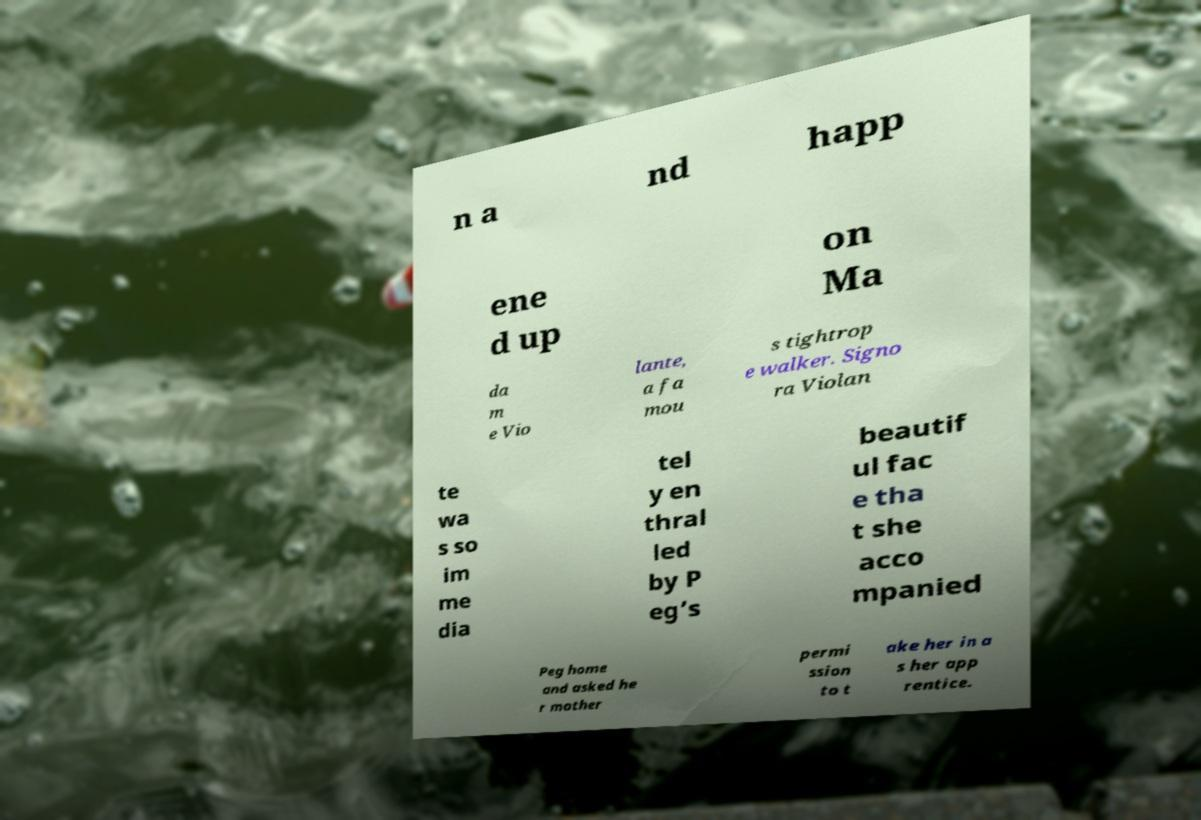What messages or text are displayed in this image? I need them in a readable, typed format. n a nd happ ene d up on Ma da m e Vio lante, a fa mou s tightrop e walker. Signo ra Violan te wa s so im me dia tel y en thral led by P eg’s beautif ul fac e tha t she acco mpanied Peg home and asked he r mother permi ssion to t ake her in a s her app rentice. 